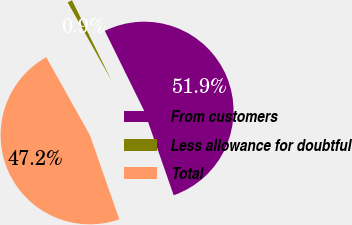Convert chart to OTSL. <chart><loc_0><loc_0><loc_500><loc_500><pie_chart><fcel>From customers<fcel>Less allowance for doubtful<fcel>Total<nl><fcel>51.93%<fcel>0.86%<fcel>47.21%<nl></chart> 